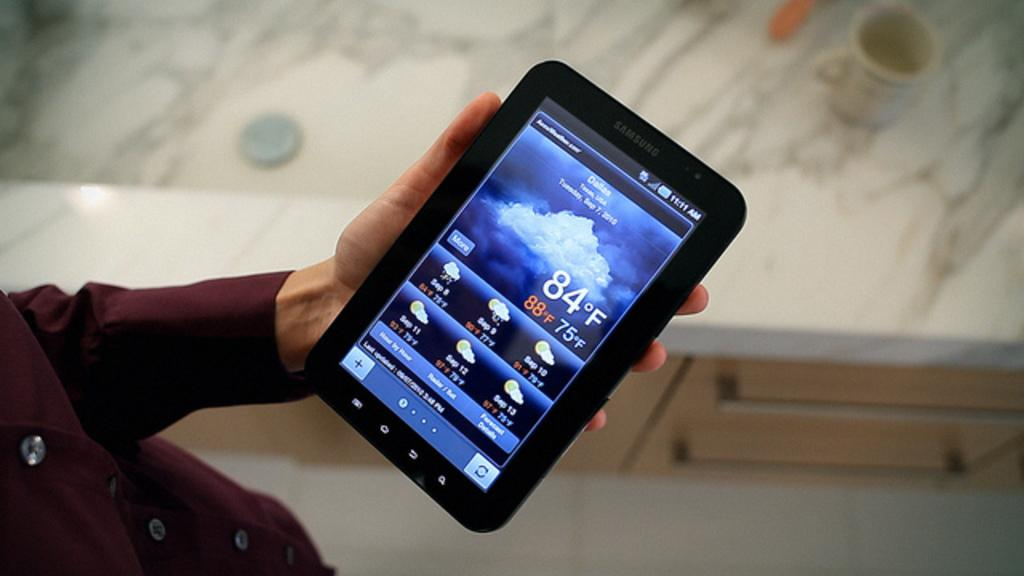What is the main subject of the image? There is a human in the image. What is the human holding in the image? The human is holding a Samsung tab. What type of clothing is the human wearing? The human is wearing a shirt. How many hours does the army of flocks in the image consist of? There is no army or flock present in the image; it features a human holding a Samsung tab while wearing a shirt. 